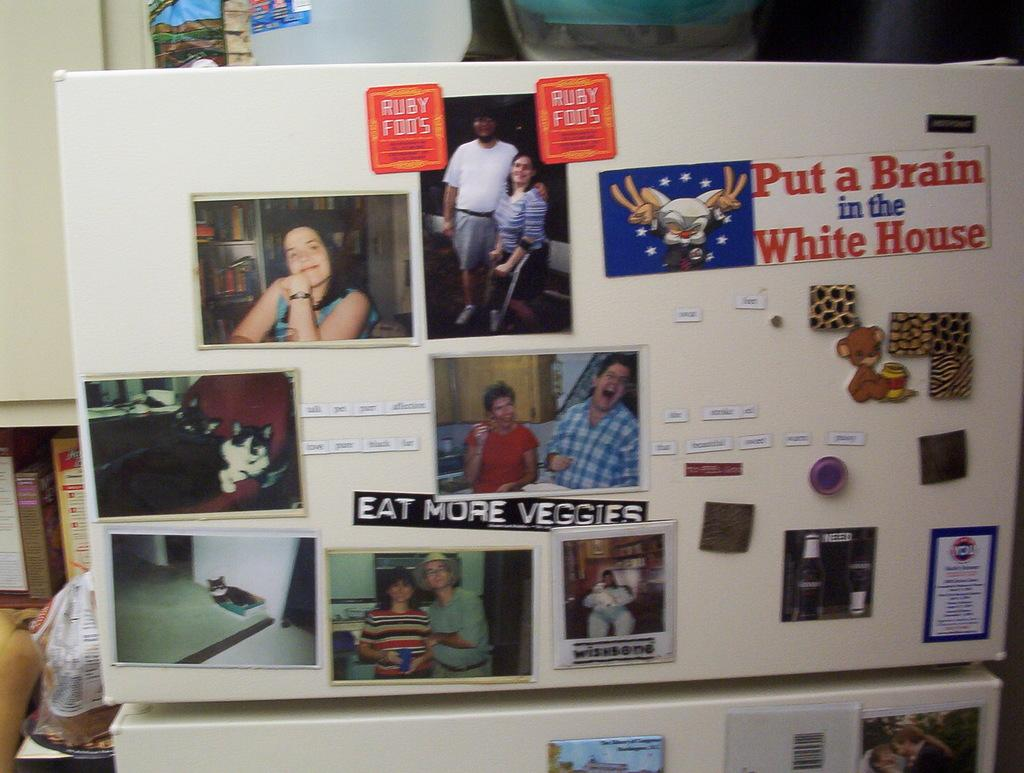What is the main object in the image? There is a whiteboard in the image. What is displayed on the whiteboard? The whiteboard has photos and stickers on it. What can be seen in the background of the image? There is a wall and racks with books in the background of the image. What type of gun is visible on the whiteboard in the image? There is no gun present on the whiteboard or in the image. 